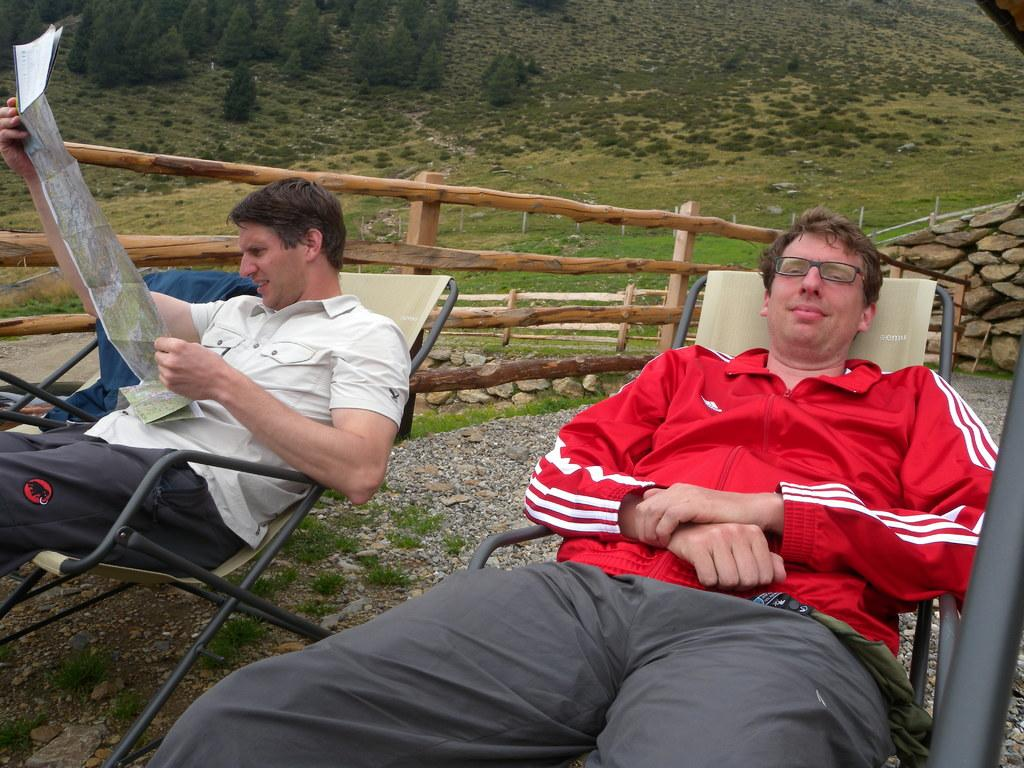How many people are in the image? There are two men in the image. What are the men doing in the image? The men are lying on chairs. Can you describe what the person on the left side is holding? The person on the left side is holding a paper. What can be seen in the background of the image? There is a wooden fence in the background of the image. What type of vest is the servant wearing in the image? There is no servant or vest present in the image. Can you provide an example of a similar situation to the one depicted in the image? It is not possible to provide an example of a similar situation based solely on the information provided in the image. 